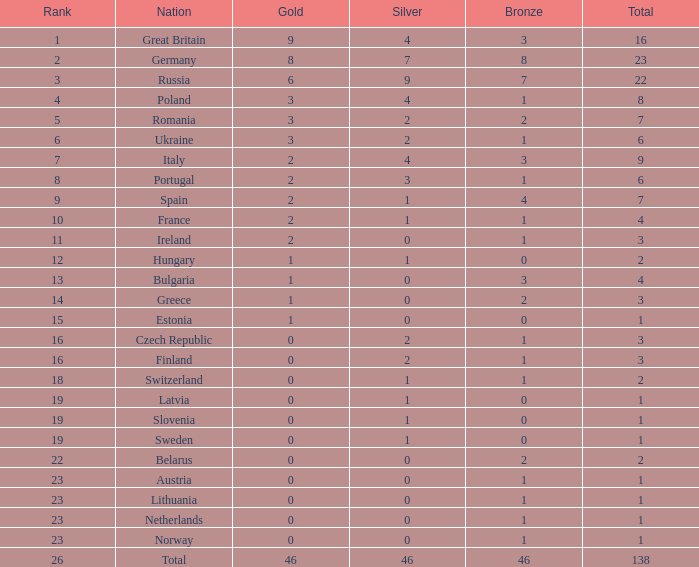Would you mind parsing the complete table? {'header': ['Rank', 'Nation', 'Gold', 'Silver', 'Bronze', 'Total'], 'rows': [['1', 'Great Britain', '9', '4', '3', '16'], ['2', 'Germany', '8', '7', '8', '23'], ['3', 'Russia', '6', '9', '7', '22'], ['4', 'Poland', '3', '4', '1', '8'], ['5', 'Romania', '3', '2', '2', '7'], ['6', 'Ukraine', '3', '2', '1', '6'], ['7', 'Italy', '2', '4', '3', '9'], ['8', 'Portugal', '2', '3', '1', '6'], ['9', 'Spain', '2', '1', '4', '7'], ['10', 'France', '2', '1', '1', '4'], ['11', 'Ireland', '2', '0', '1', '3'], ['12', 'Hungary', '1', '1', '0', '2'], ['13', 'Bulgaria', '1', '0', '3', '4'], ['14', 'Greece', '1', '0', '2', '3'], ['15', 'Estonia', '1', '0', '0', '1'], ['16', 'Czech Republic', '0', '2', '1', '3'], ['16', 'Finland', '0', '2', '1', '3'], ['18', 'Switzerland', '0', '1', '1', '2'], ['19', 'Latvia', '0', '1', '0', '1'], ['19', 'Slovenia', '0', '1', '0', '1'], ['19', 'Sweden', '0', '1', '0', '1'], ['22', 'Belarus', '0', '0', '2', '2'], ['23', 'Austria', '0', '0', '1', '1'], ['23', 'Lithuania', '0', '0', '1', '1'], ['23', 'Netherlands', '0', '0', '1', '1'], ['23', 'Norway', '0', '0', '1', '1'], ['26', 'Total', '46', '46', '46', '138']]} What is the complete number for a total when the nation is holland and silver is more than 0? 0.0. 